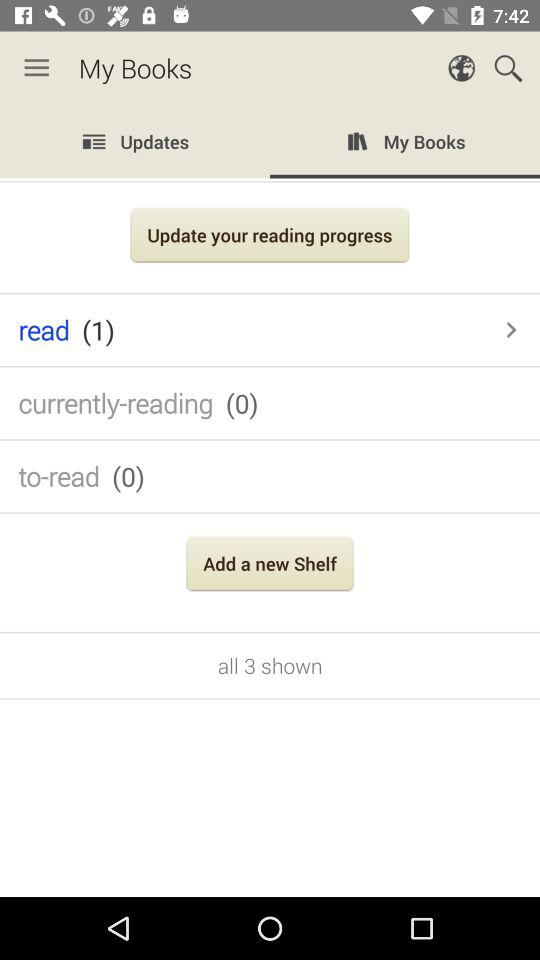How many books in total are read? There is 1 book in total that is read. 